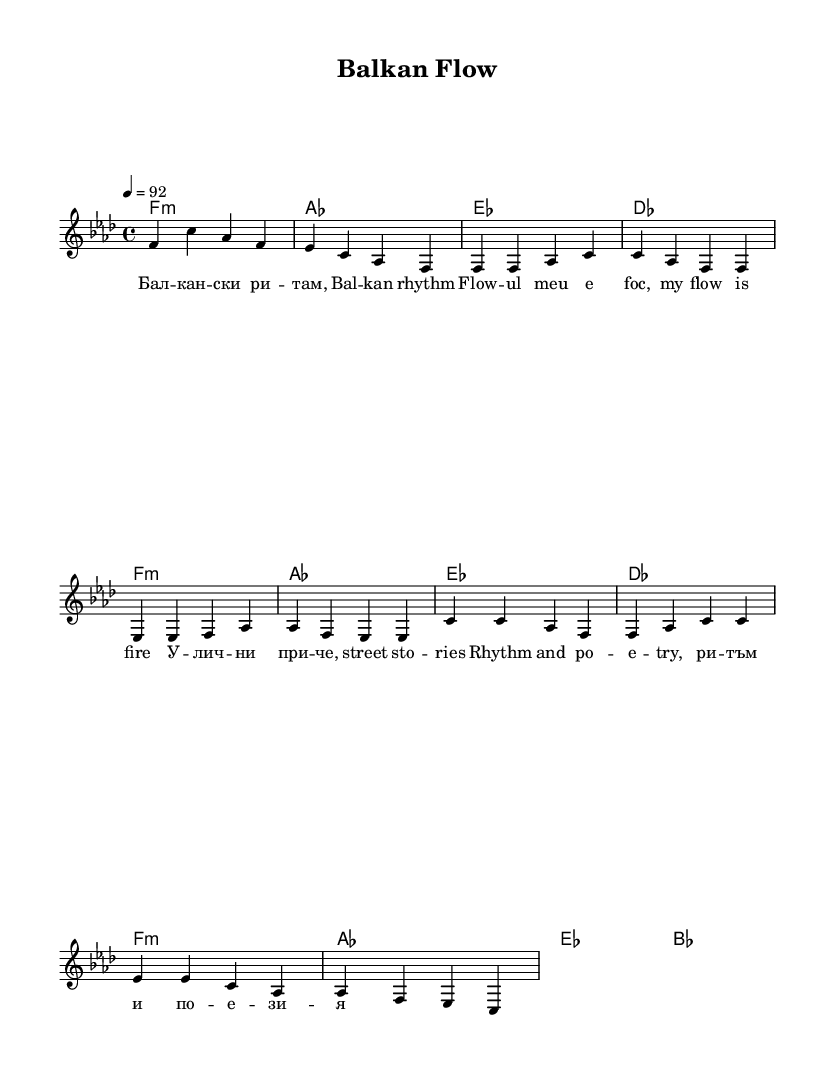What is the key signature of this music? The key signature is F minor, indicated by the presence of four flats (B♭, E♭, A♭, D♭) in the music sheet.
Answer: F minor What is the time signature of this music? The time signature is 4/4, which is commonly used in rap music, characterized by four beats in each measure.
Answer: 4/4 What is the tempo marking of the piece? The tempo marking indicates a speed of quarter note equals 92 beats per minute, which provides a moderate pace suitable for rap delivery.
Answer: 92 How many measures are in the verse? The verse consists of four measures, as evidenced by the grouping of notes and corresponding lyrics that fit within this section.
Answer: 4 What language is primarily used in the lyrics? The lyrics incorporate multiple languages, but the primary language observed is Macedonian, noted by the use of Cyrillic script and phrases specific to the region.
Answer: Macedonian What is the motif of the lyrics? The lyrics convey themes of street life and personal identity, common in rap, and express a blend of Eastern European cultural elements and experiences.
Answer: Street life How is the structure of the rap indicated in the sheet music? The structure is indicated by the separation of sections such as "Intro," "Verse," and "Chorus," which denotes the overall organization typical of rap songs.
Answer: Intro, Verse, Chorus 